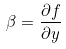<formula> <loc_0><loc_0><loc_500><loc_500>\beta = \frac { \partial f } { \partial y }</formula> 